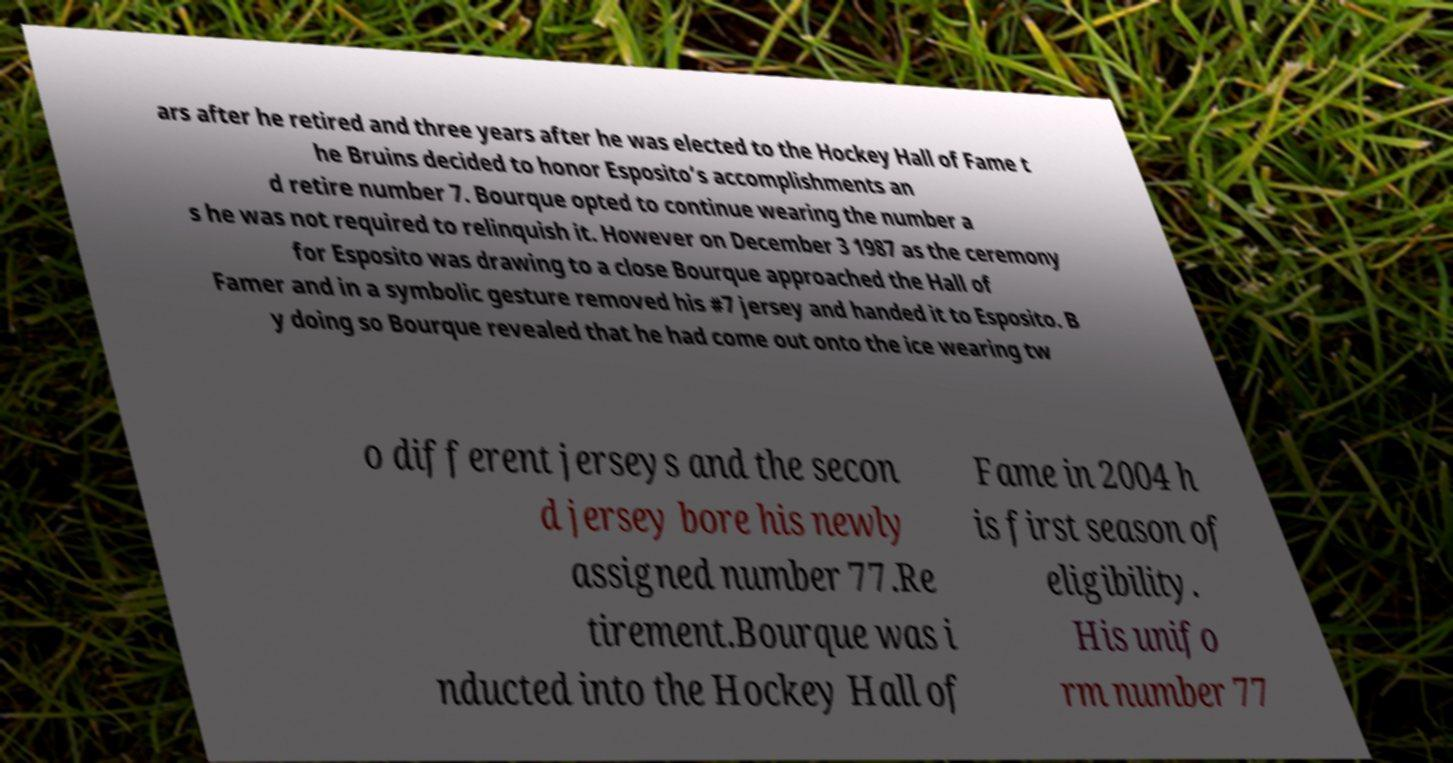Please read and relay the text visible in this image. What does it say? ars after he retired and three years after he was elected to the Hockey Hall of Fame t he Bruins decided to honor Esposito’s accomplishments an d retire number 7. Bourque opted to continue wearing the number a s he was not required to relinquish it. However on December 3 1987 as the ceremony for Esposito was drawing to a close Bourque approached the Hall of Famer and in a symbolic gesture removed his #7 jersey and handed it to Esposito. B y doing so Bourque revealed that he had come out onto the ice wearing tw o different jerseys and the secon d jersey bore his newly assigned number 77.Re tirement.Bourque was i nducted into the Hockey Hall of Fame in 2004 h is first season of eligibility. His unifo rm number 77 